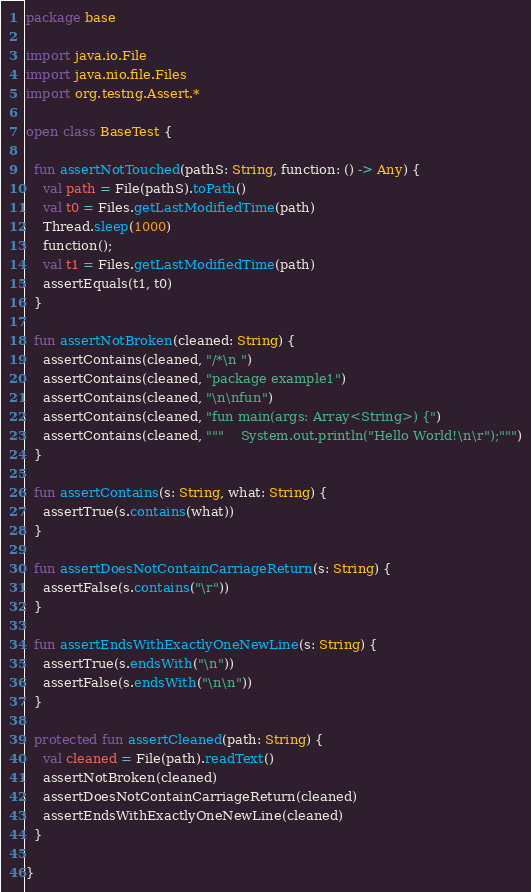Convert code to text. <code><loc_0><loc_0><loc_500><loc_500><_Kotlin_>package base

import java.io.File
import java.nio.file.Files
import org.testng.Assert.*

open class BaseTest {

  fun assertNotTouched(pathS: String, function: () -> Any) {
    val path = File(pathS).toPath()
    val t0 = Files.getLastModifiedTime(path)
    Thread.sleep(1000)
    function();
    val t1 = Files.getLastModifiedTime(path)
    assertEquals(t1, t0)
  }

  fun assertNotBroken(cleaned: String) {
    assertContains(cleaned, "/*\n ")
    assertContains(cleaned, "package example1")
    assertContains(cleaned, "\n\nfun")
    assertContains(cleaned, "fun main(args: Array<String>) {")
    assertContains(cleaned, """    System.out.println("Hello World!\n\r");""")
  }

  fun assertContains(s: String, what: String) {
    assertTrue(s.contains(what))
  }

  fun assertDoesNotContainCarriageReturn(s: String) {
    assertFalse(s.contains("\r"))
  }

  fun assertEndsWithExactlyOneNewLine(s: String) {
    assertTrue(s.endsWith("\n"))
    assertFalse(s.endsWith("\n\n"))
  }

  protected fun assertCleaned(path: String) {
    val cleaned = File(path).readText()
    assertNotBroken(cleaned)
    assertDoesNotContainCarriageReturn(cleaned)
    assertEndsWithExactlyOneNewLine(cleaned)
  }

}
</code> 